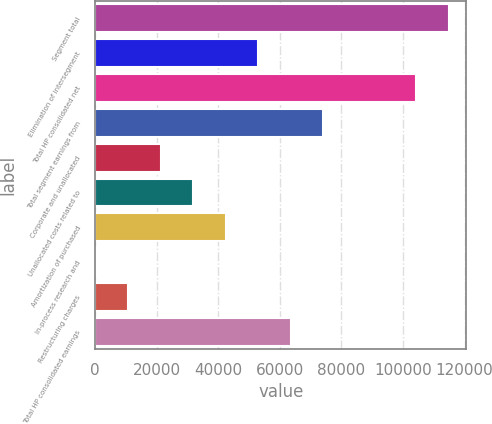<chart> <loc_0><loc_0><loc_500><loc_500><bar_chart><fcel>Segment total<fcel>Elimination of intersegment<fcel>Total HP consolidated net<fcel>Total segment earnings from<fcel>Corporate and unallocated<fcel>Unallocated costs related to<fcel>Amortization of purchased<fcel>In-process research and<fcel>Restructuring charges<fcel>Total HP consolidated earnings<nl><fcel>114838<fcel>52951<fcel>104286<fcel>74055.4<fcel>21294.4<fcel>31846.6<fcel>42398.8<fcel>190<fcel>10742.2<fcel>63503.2<nl></chart> 